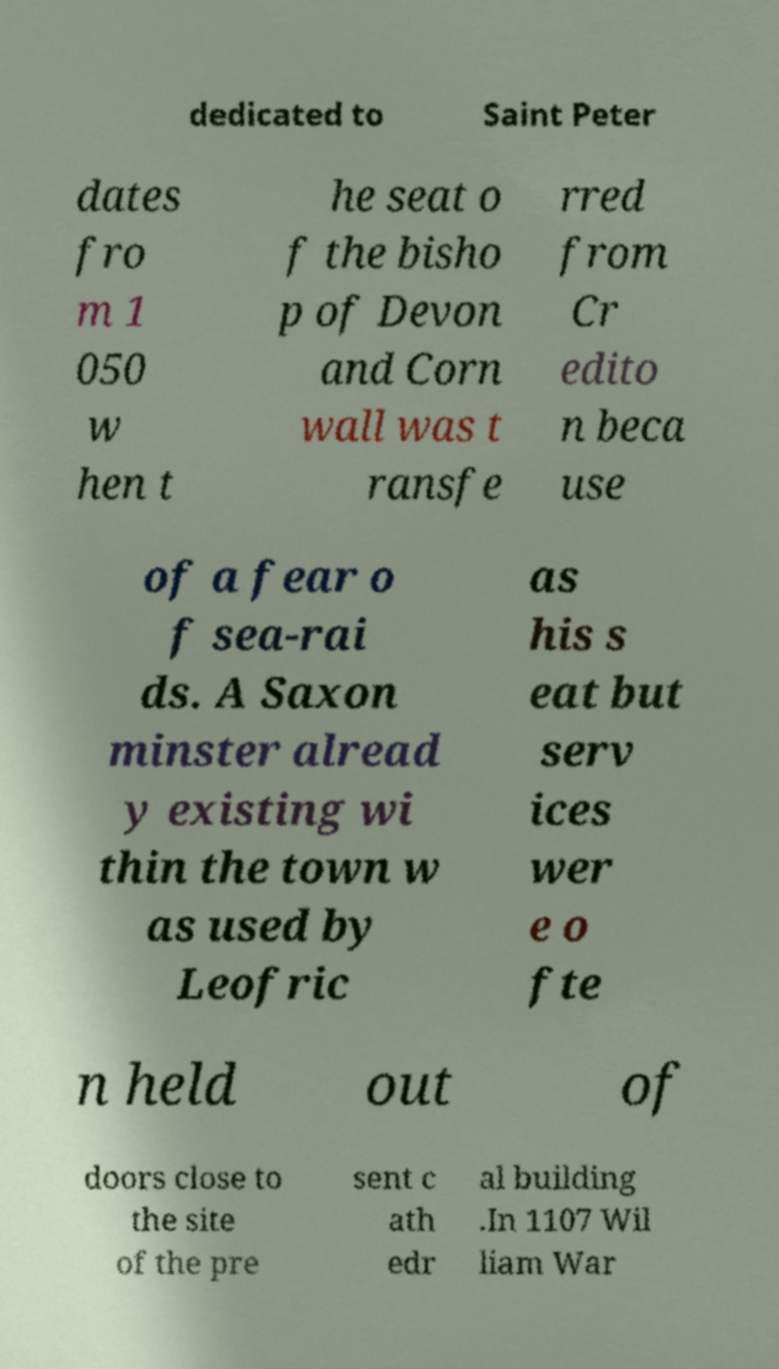I need the written content from this picture converted into text. Can you do that? dedicated to Saint Peter dates fro m 1 050 w hen t he seat o f the bisho p of Devon and Corn wall was t ransfe rred from Cr edito n beca use of a fear o f sea-rai ds. A Saxon minster alread y existing wi thin the town w as used by Leofric as his s eat but serv ices wer e o fte n held out of doors close to the site of the pre sent c ath edr al building .In 1107 Wil liam War 